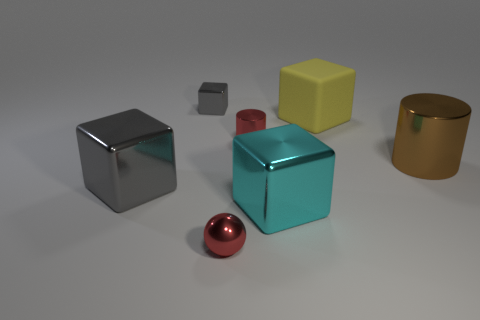The other metal cube that is the same color as the tiny block is what size?
Provide a succinct answer. Large. Are there any brown rubber things of the same size as the cyan metal thing?
Your response must be concise. No. Are there any large objects to the left of the red object that is in front of the large metallic thing that is to the right of the yellow rubber thing?
Keep it short and to the point. Yes. There is a small sphere; is it the same color as the tiny shiny cylinder behind the large gray shiny block?
Ensure brevity in your answer.  Yes. What is the cylinder that is on the right side of the large metal cube that is right of the gray metal object behind the large brown cylinder made of?
Your response must be concise. Metal. What is the shape of the red metal thing behind the small red shiny sphere?
Ensure brevity in your answer.  Cylinder. There is a ball that is the same material as the tiny gray object; what size is it?
Keep it short and to the point. Small. How many gray things have the same shape as the large brown thing?
Provide a short and direct response. 0. Is the color of the cylinder that is on the left side of the large yellow rubber block the same as the sphere?
Your answer should be very brief. Yes. There is a red thing in front of the small red object that is behind the small red sphere; what number of large yellow cubes are on the right side of it?
Keep it short and to the point. 1. 